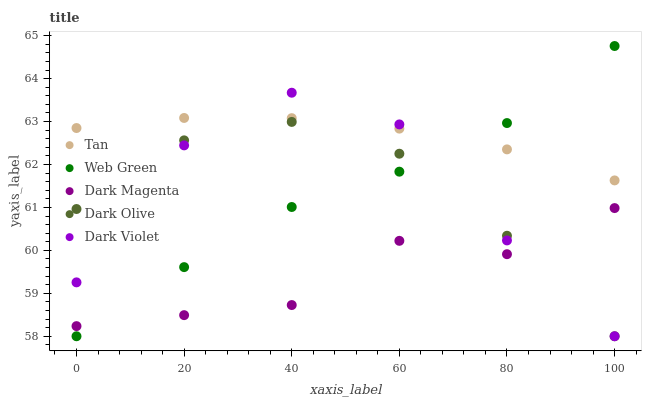Does Dark Magenta have the minimum area under the curve?
Answer yes or no. Yes. Does Tan have the maximum area under the curve?
Answer yes or no. Yes. Does Dark Olive have the minimum area under the curve?
Answer yes or no. No. Does Dark Olive have the maximum area under the curve?
Answer yes or no. No. Is Tan the smoothest?
Answer yes or no. Yes. Is Dark Violet the roughest?
Answer yes or no. Yes. Is Dark Olive the smoothest?
Answer yes or no. No. Is Dark Olive the roughest?
Answer yes or no. No. Does Dark Olive have the lowest value?
Answer yes or no. Yes. Does Dark Magenta have the lowest value?
Answer yes or no. No. Does Web Green have the highest value?
Answer yes or no. Yes. Does Dark Olive have the highest value?
Answer yes or no. No. Is Dark Olive less than Tan?
Answer yes or no. Yes. Is Tan greater than Dark Magenta?
Answer yes or no. Yes. Does Dark Olive intersect Dark Violet?
Answer yes or no. Yes. Is Dark Olive less than Dark Violet?
Answer yes or no. No. Is Dark Olive greater than Dark Violet?
Answer yes or no. No. Does Dark Olive intersect Tan?
Answer yes or no. No. 